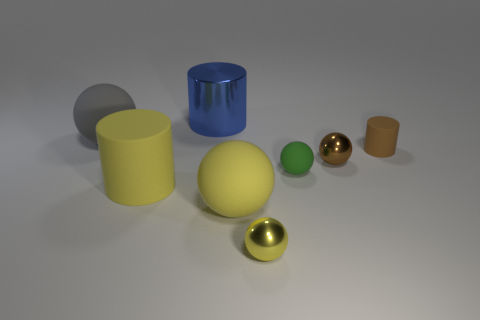Subtract all gray spheres. How many spheres are left? 4 Subtract all gray spheres. How many spheres are left? 4 Subtract all cyan spheres. Subtract all green cylinders. How many spheres are left? 5 Add 1 large brown rubber things. How many objects exist? 9 Subtract all cylinders. How many objects are left? 5 Add 1 blue shiny cylinders. How many blue shiny cylinders are left? 2 Add 2 tiny yellow shiny balls. How many tiny yellow shiny balls exist? 3 Subtract 0 blue balls. How many objects are left? 8 Subtract all gray matte spheres. Subtract all brown matte objects. How many objects are left? 6 